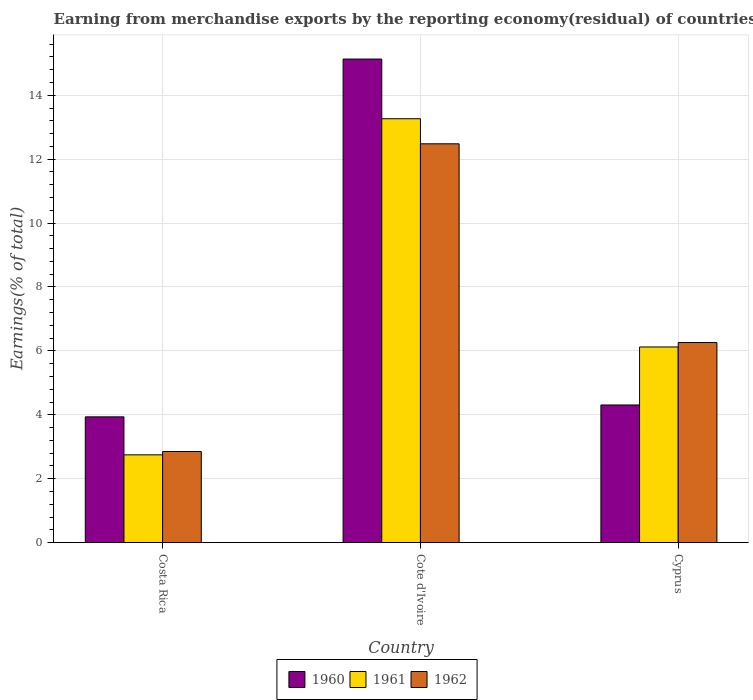Are the number of bars per tick equal to the number of legend labels?
Keep it short and to the point. Yes. How many bars are there on the 3rd tick from the left?
Your answer should be compact. 3. What is the label of the 3rd group of bars from the left?
Keep it short and to the point. Cyprus. What is the percentage of amount earned from merchandise exports in 1962 in Cote d'Ivoire?
Your response must be concise. 12.48. Across all countries, what is the maximum percentage of amount earned from merchandise exports in 1960?
Ensure brevity in your answer.  15.13. Across all countries, what is the minimum percentage of amount earned from merchandise exports in 1962?
Your response must be concise. 2.85. In which country was the percentage of amount earned from merchandise exports in 1962 maximum?
Your answer should be very brief. Cote d'Ivoire. What is the total percentage of amount earned from merchandise exports in 1961 in the graph?
Ensure brevity in your answer.  22.13. What is the difference between the percentage of amount earned from merchandise exports in 1960 in Cote d'Ivoire and that in Cyprus?
Give a very brief answer. 10.83. What is the difference between the percentage of amount earned from merchandise exports in 1962 in Costa Rica and the percentage of amount earned from merchandise exports in 1961 in Cote d'Ivoire?
Provide a succinct answer. -10.42. What is the average percentage of amount earned from merchandise exports in 1962 per country?
Ensure brevity in your answer.  7.2. What is the difference between the percentage of amount earned from merchandise exports of/in 1960 and percentage of amount earned from merchandise exports of/in 1961 in Cyprus?
Keep it short and to the point. -1.82. What is the ratio of the percentage of amount earned from merchandise exports in 1962 in Costa Rica to that in Cyprus?
Ensure brevity in your answer.  0.46. Is the difference between the percentage of amount earned from merchandise exports in 1960 in Cote d'Ivoire and Cyprus greater than the difference between the percentage of amount earned from merchandise exports in 1961 in Cote d'Ivoire and Cyprus?
Keep it short and to the point. Yes. What is the difference between the highest and the second highest percentage of amount earned from merchandise exports in 1960?
Ensure brevity in your answer.  -0.37. What is the difference between the highest and the lowest percentage of amount earned from merchandise exports in 1962?
Keep it short and to the point. 9.63. What does the 3rd bar from the right in Cyprus represents?
Provide a succinct answer. 1960. Is it the case that in every country, the sum of the percentage of amount earned from merchandise exports in 1962 and percentage of amount earned from merchandise exports in 1960 is greater than the percentage of amount earned from merchandise exports in 1961?
Keep it short and to the point. Yes. How many bars are there?
Offer a very short reply. 9. How many countries are there in the graph?
Ensure brevity in your answer.  3. What is the difference between two consecutive major ticks on the Y-axis?
Ensure brevity in your answer.  2. Are the values on the major ticks of Y-axis written in scientific E-notation?
Your response must be concise. No. Where does the legend appear in the graph?
Your response must be concise. Bottom center. How many legend labels are there?
Provide a short and direct response. 3. How are the legend labels stacked?
Give a very brief answer. Horizontal. What is the title of the graph?
Make the answer very short. Earning from merchandise exports by the reporting economy(residual) of countries. Does "2004" appear as one of the legend labels in the graph?
Offer a terse response. No. What is the label or title of the X-axis?
Provide a short and direct response. Country. What is the label or title of the Y-axis?
Provide a succinct answer. Earnings(% of total). What is the Earnings(% of total) in 1960 in Costa Rica?
Keep it short and to the point. 3.94. What is the Earnings(% of total) in 1961 in Costa Rica?
Offer a very short reply. 2.75. What is the Earnings(% of total) of 1962 in Costa Rica?
Your response must be concise. 2.85. What is the Earnings(% of total) of 1960 in Cote d'Ivoire?
Give a very brief answer. 15.13. What is the Earnings(% of total) of 1961 in Cote d'Ivoire?
Keep it short and to the point. 13.27. What is the Earnings(% of total) in 1962 in Cote d'Ivoire?
Keep it short and to the point. 12.48. What is the Earnings(% of total) of 1960 in Cyprus?
Give a very brief answer. 4.31. What is the Earnings(% of total) of 1961 in Cyprus?
Your answer should be compact. 6.12. What is the Earnings(% of total) of 1962 in Cyprus?
Your answer should be very brief. 6.26. Across all countries, what is the maximum Earnings(% of total) in 1960?
Give a very brief answer. 15.13. Across all countries, what is the maximum Earnings(% of total) in 1961?
Make the answer very short. 13.27. Across all countries, what is the maximum Earnings(% of total) of 1962?
Your answer should be compact. 12.48. Across all countries, what is the minimum Earnings(% of total) of 1960?
Your answer should be very brief. 3.94. Across all countries, what is the minimum Earnings(% of total) of 1961?
Keep it short and to the point. 2.75. Across all countries, what is the minimum Earnings(% of total) in 1962?
Your answer should be compact. 2.85. What is the total Earnings(% of total) in 1960 in the graph?
Your answer should be compact. 23.38. What is the total Earnings(% of total) in 1961 in the graph?
Make the answer very short. 22.13. What is the total Earnings(% of total) in 1962 in the graph?
Your answer should be very brief. 21.59. What is the difference between the Earnings(% of total) in 1960 in Costa Rica and that in Cote d'Ivoire?
Provide a short and direct response. -11.2. What is the difference between the Earnings(% of total) of 1961 in Costa Rica and that in Cote d'Ivoire?
Your answer should be compact. -10.52. What is the difference between the Earnings(% of total) in 1962 in Costa Rica and that in Cote d'Ivoire?
Offer a very short reply. -9.63. What is the difference between the Earnings(% of total) of 1960 in Costa Rica and that in Cyprus?
Keep it short and to the point. -0.37. What is the difference between the Earnings(% of total) of 1961 in Costa Rica and that in Cyprus?
Offer a very short reply. -3.38. What is the difference between the Earnings(% of total) of 1962 in Costa Rica and that in Cyprus?
Offer a very short reply. -3.41. What is the difference between the Earnings(% of total) in 1960 in Cote d'Ivoire and that in Cyprus?
Keep it short and to the point. 10.83. What is the difference between the Earnings(% of total) of 1961 in Cote d'Ivoire and that in Cyprus?
Offer a very short reply. 7.14. What is the difference between the Earnings(% of total) in 1962 in Cote d'Ivoire and that in Cyprus?
Your response must be concise. 6.22. What is the difference between the Earnings(% of total) in 1960 in Costa Rica and the Earnings(% of total) in 1961 in Cote d'Ivoire?
Ensure brevity in your answer.  -9.33. What is the difference between the Earnings(% of total) in 1960 in Costa Rica and the Earnings(% of total) in 1962 in Cote d'Ivoire?
Your answer should be very brief. -8.55. What is the difference between the Earnings(% of total) of 1961 in Costa Rica and the Earnings(% of total) of 1962 in Cote d'Ivoire?
Offer a very short reply. -9.73. What is the difference between the Earnings(% of total) of 1960 in Costa Rica and the Earnings(% of total) of 1961 in Cyprus?
Provide a short and direct response. -2.19. What is the difference between the Earnings(% of total) in 1960 in Costa Rica and the Earnings(% of total) in 1962 in Cyprus?
Your answer should be very brief. -2.33. What is the difference between the Earnings(% of total) of 1961 in Costa Rica and the Earnings(% of total) of 1962 in Cyprus?
Your response must be concise. -3.51. What is the difference between the Earnings(% of total) in 1960 in Cote d'Ivoire and the Earnings(% of total) in 1961 in Cyprus?
Provide a short and direct response. 9.01. What is the difference between the Earnings(% of total) of 1960 in Cote d'Ivoire and the Earnings(% of total) of 1962 in Cyprus?
Provide a succinct answer. 8.87. What is the difference between the Earnings(% of total) of 1961 in Cote d'Ivoire and the Earnings(% of total) of 1962 in Cyprus?
Ensure brevity in your answer.  7. What is the average Earnings(% of total) in 1960 per country?
Give a very brief answer. 7.79. What is the average Earnings(% of total) in 1961 per country?
Offer a terse response. 7.38. What is the average Earnings(% of total) in 1962 per country?
Provide a short and direct response. 7.2. What is the difference between the Earnings(% of total) in 1960 and Earnings(% of total) in 1961 in Costa Rica?
Your answer should be very brief. 1.19. What is the difference between the Earnings(% of total) in 1960 and Earnings(% of total) in 1962 in Costa Rica?
Provide a succinct answer. 1.08. What is the difference between the Earnings(% of total) in 1961 and Earnings(% of total) in 1962 in Costa Rica?
Offer a terse response. -0.1. What is the difference between the Earnings(% of total) of 1960 and Earnings(% of total) of 1961 in Cote d'Ivoire?
Keep it short and to the point. 1.87. What is the difference between the Earnings(% of total) of 1960 and Earnings(% of total) of 1962 in Cote d'Ivoire?
Your answer should be compact. 2.65. What is the difference between the Earnings(% of total) in 1961 and Earnings(% of total) in 1962 in Cote d'Ivoire?
Your answer should be very brief. 0.79. What is the difference between the Earnings(% of total) of 1960 and Earnings(% of total) of 1961 in Cyprus?
Keep it short and to the point. -1.82. What is the difference between the Earnings(% of total) of 1960 and Earnings(% of total) of 1962 in Cyprus?
Give a very brief answer. -1.95. What is the difference between the Earnings(% of total) in 1961 and Earnings(% of total) in 1962 in Cyprus?
Make the answer very short. -0.14. What is the ratio of the Earnings(% of total) in 1960 in Costa Rica to that in Cote d'Ivoire?
Your answer should be compact. 0.26. What is the ratio of the Earnings(% of total) in 1961 in Costa Rica to that in Cote d'Ivoire?
Your answer should be very brief. 0.21. What is the ratio of the Earnings(% of total) of 1962 in Costa Rica to that in Cote d'Ivoire?
Keep it short and to the point. 0.23. What is the ratio of the Earnings(% of total) in 1960 in Costa Rica to that in Cyprus?
Give a very brief answer. 0.91. What is the ratio of the Earnings(% of total) of 1961 in Costa Rica to that in Cyprus?
Give a very brief answer. 0.45. What is the ratio of the Earnings(% of total) in 1962 in Costa Rica to that in Cyprus?
Provide a short and direct response. 0.46. What is the ratio of the Earnings(% of total) in 1960 in Cote d'Ivoire to that in Cyprus?
Offer a very short reply. 3.51. What is the ratio of the Earnings(% of total) in 1961 in Cote d'Ivoire to that in Cyprus?
Make the answer very short. 2.17. What is the ratio of the Earnings(% of total) of 1962 in Cote d'Ivoire to that in Cyprus?
Keep it short and to the point. 1.99. What is the difference between the highest and the second highest Earnings(% of total) of 1960?
Ensure brevity in your answer.  10.83. What is the difference between the highest and the second highest Earnings(% of total) in 1961?
Keep it short and to the point. 7.14. What is the difference between the highest and the second highest Earnings(% of total) of 1962?
Provide a short and direct response. 6.22. What is the difference between the highest and the lowest Earnings(% of total) of 1960?
Give a very brief answer. 11.2. What is the difference between the highest and the lowest Earnings(% of total) of 1961?
Provide a short and direct response. 10.52. What is the difference between the highest and the lowest Earnings(% of total) of 1962?
Ensure brevity in your answer.  9.63. 